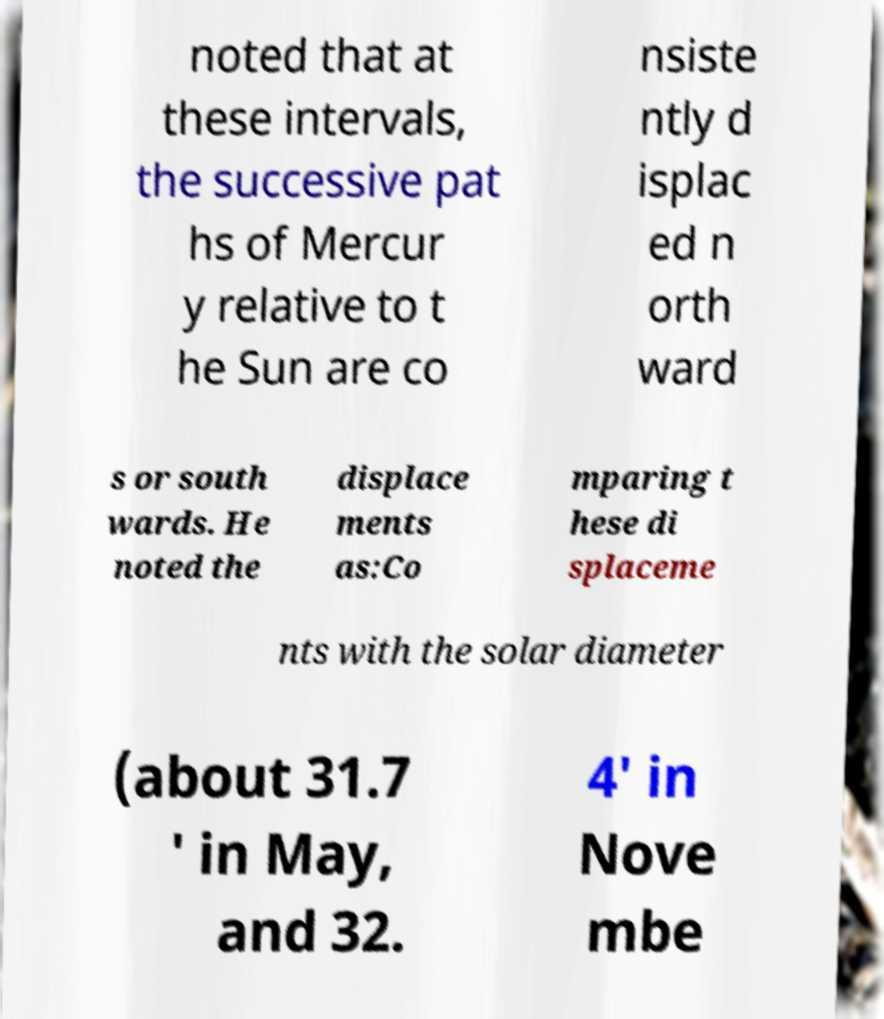What messages or text are displayed in this image? I need them in a readable, typed format. noted that at these intervals, the successive pat hs of Mercur y relative to t he Sun are co nsiste ntly d isplac ed n orth ward s or south wards. He noted the displace ments as:Co mparing t hese di splaceme nts with the solar diameter (about 31.7 ′ in May, and 32. 4′ in Nove mbe 